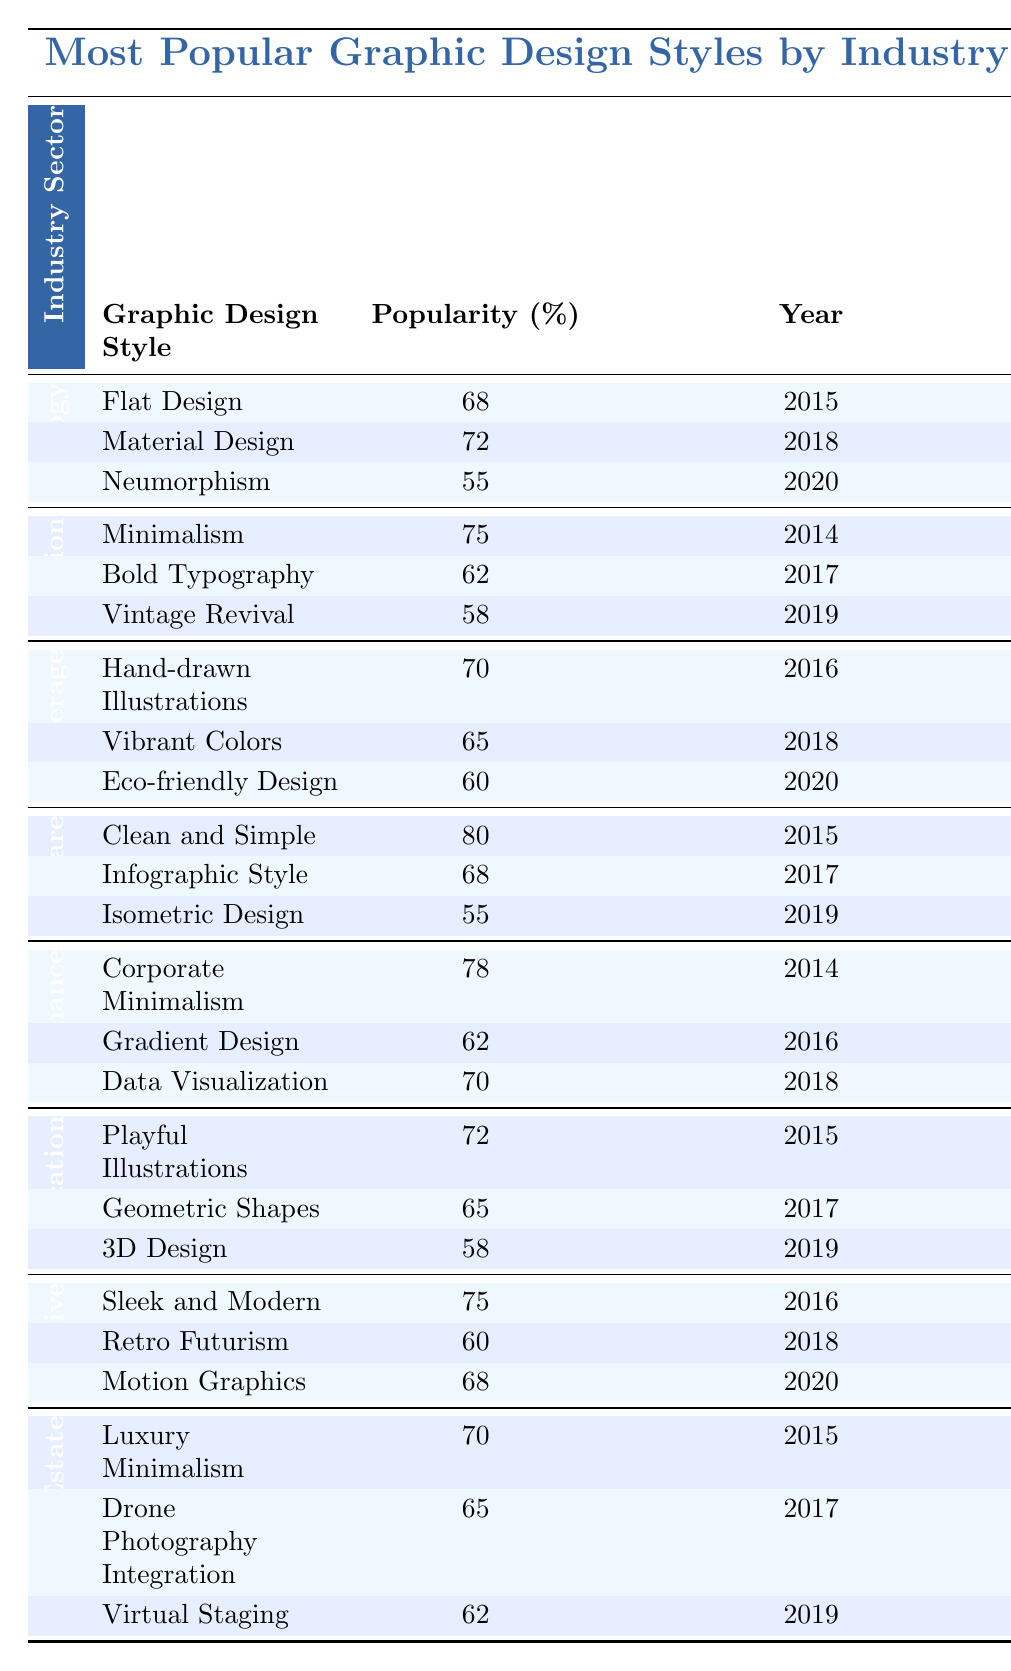What graphic design style was the most popular in the Healthcare sector in 2015? The table shows that "Clean and Simple" had the highest popularity in the Healthcare sector in 2015 with 80%.
Answer: 80% What is the popularity percentage of Vibrant Colors in the Food & Beverage sector? The table lists "Vibrant Colors" with a popularity of 65% in the Food & Beverage sector.
Answer: 65% Which graphic design style had the lowest popularity in the Technology sector? In the Technology sector, "Neumorphism" had the lowest popularity at 55%.
Answer: Neumorphism Is the popularity of Retro Futurism greater than 60%? The table indicates that "Retro Futurism" has a popularity of 60%, so it is not greater.
Answer: No Which industry sector had the highest overall popularity score in 2014? In 2014, the Finance sector had a popularity score of 78%, which is higher than any other sector listed in that year.
Answer: Finance What are the top two graphic design styles in the Automotive sector by popularity? The top two styles in the Automotive sector are "Sleek and Modern" at 75% and "Motion Graphics" at 68%.
Answer: Sleek and Modern, Motion Graphics What is the average popularity of graphic design styles in the Education sector over the years provided? The popularity values are 72%, 65%, and 58%. The average is (72 + 65 + 58) / 3 = 65%.
Answer: 65% In what year did Corporate Minimalism reach its popularity score? Corporate Minimalism reached its popularity score in the year 2014.
Answer: 2014 What percentage difference is there between the popularity of Minimalism in Fashion and Clean and Simple in Healthcare? Minimalism in Fashion has 75% and Clean and Simple in Healthcare has 80%. The difference is 80 - 75 = 5%.
Answer: 5% Which design style saw the largest decline in popularity from one year to the next in the Healthcare sector? The decline was from "Infographic Style" (68% in 2017) to "Isometric Design" (55% in 2019), a drop of 13%.
Answer: 13% decline 